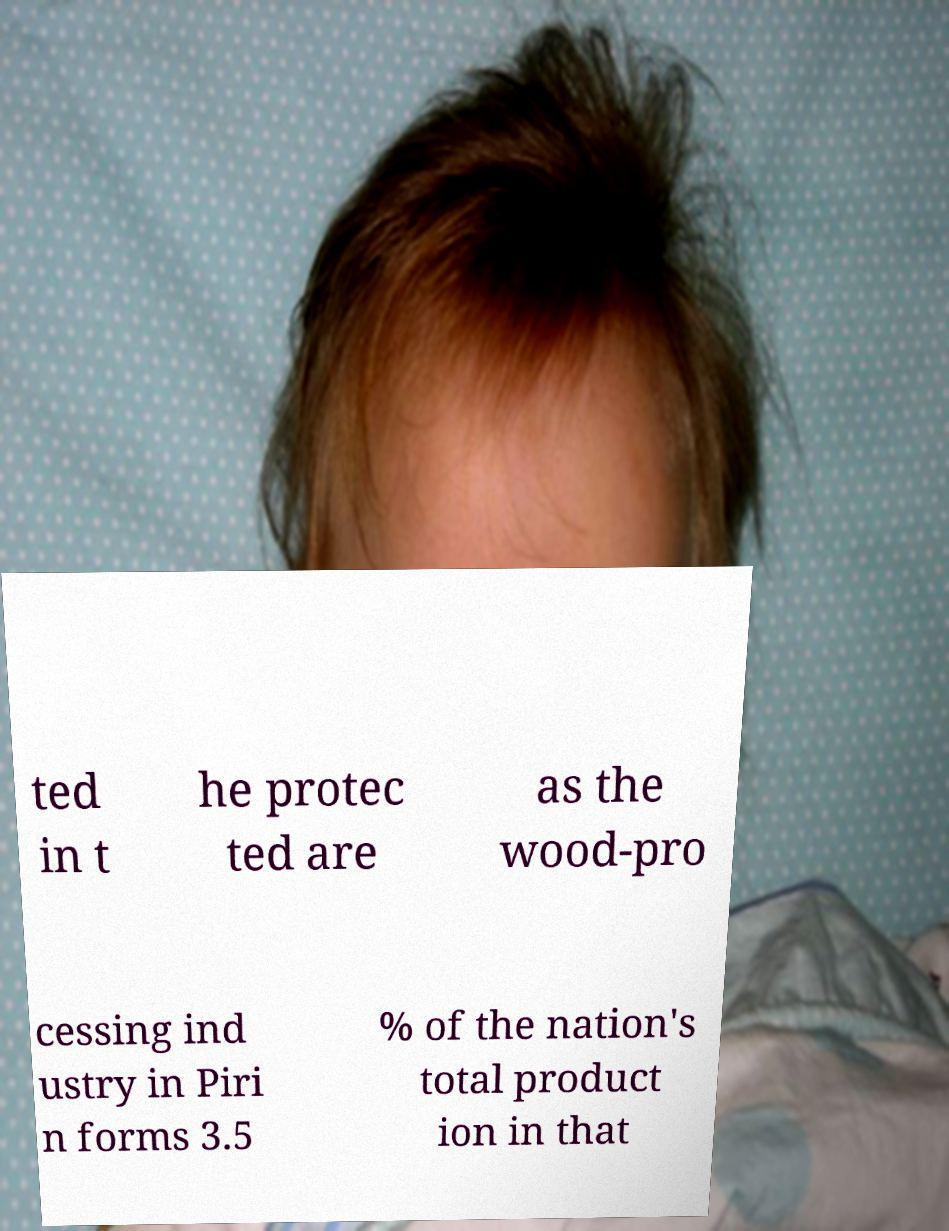There's text embedded in this image that I need extracted. Can you transcribe it verbatim? ted in t he protec ted are as the wood-pro cessing ind ustry in Piri n forms 3.5 % of the nation's total product ion in that 